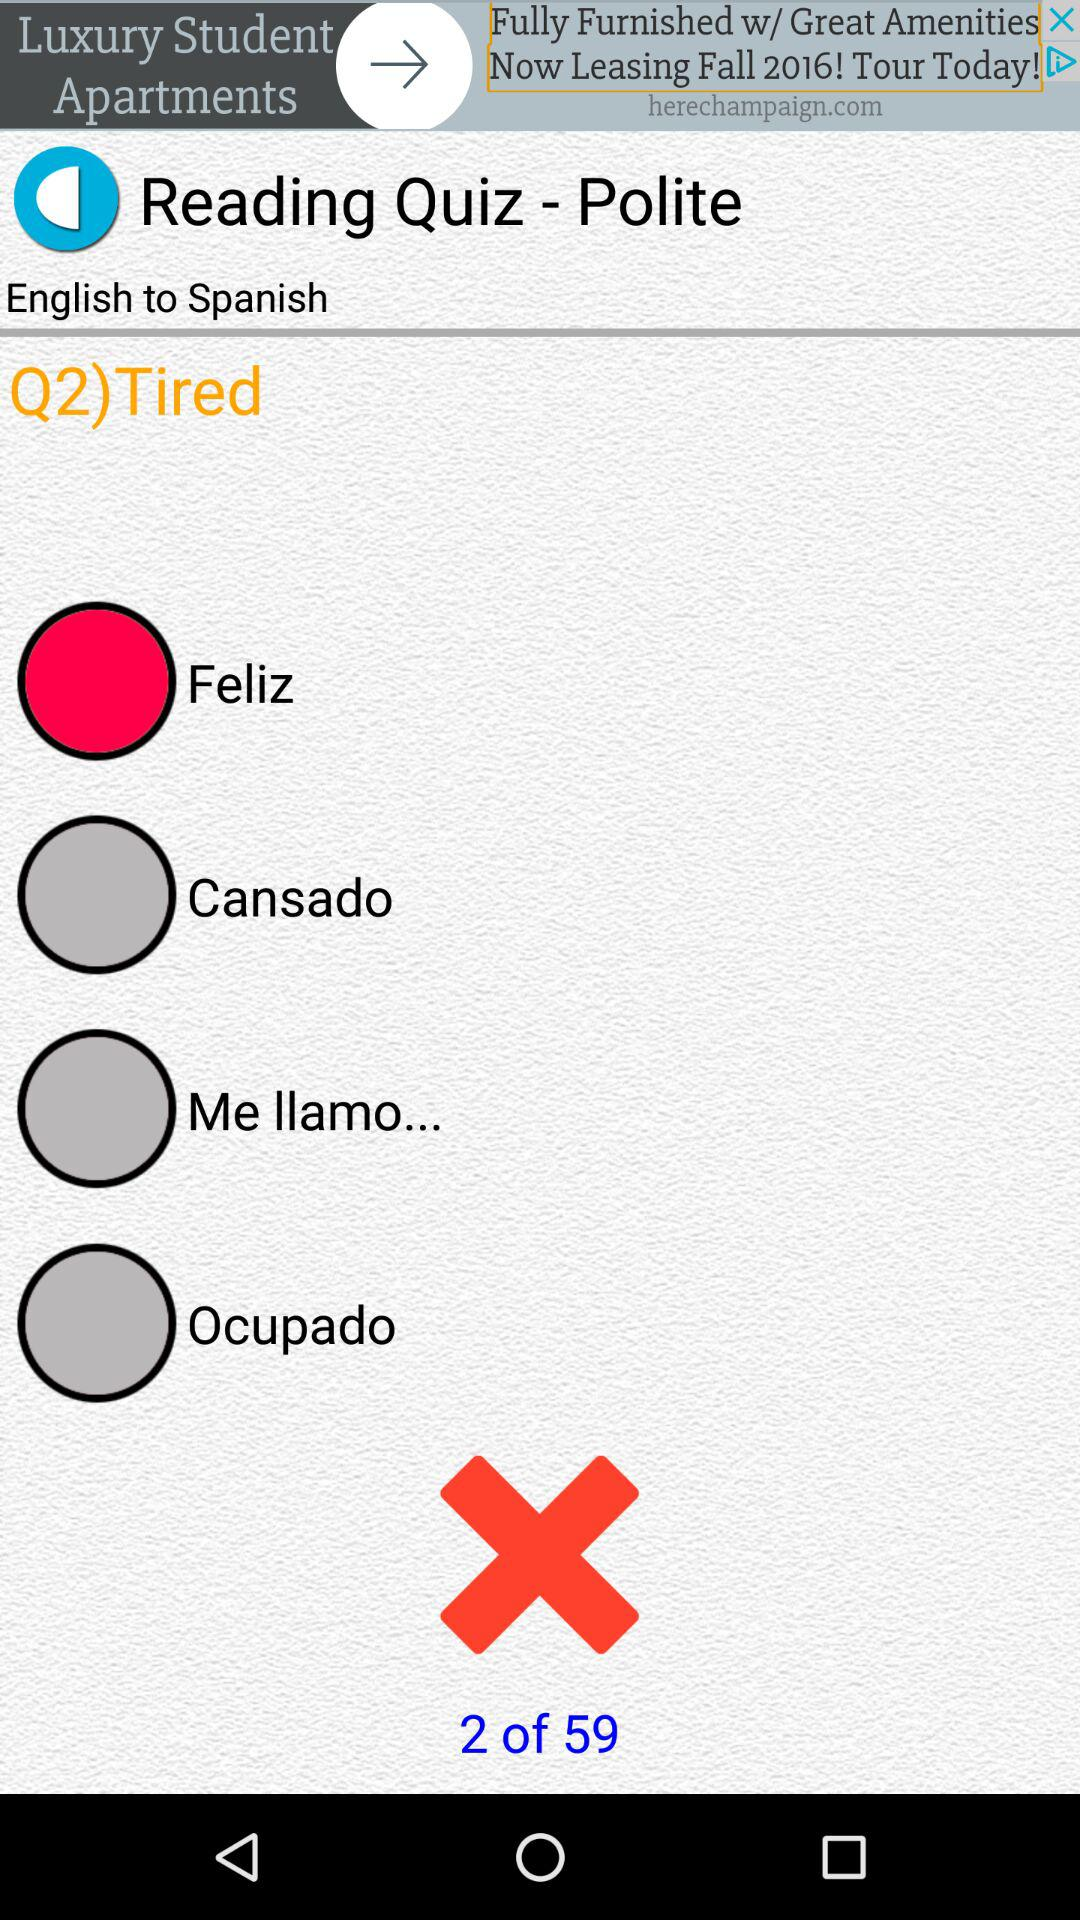What are the available answer options? The available answer options are "Feliz", "Cansado", "Me llamo..." and "Ocupado". 